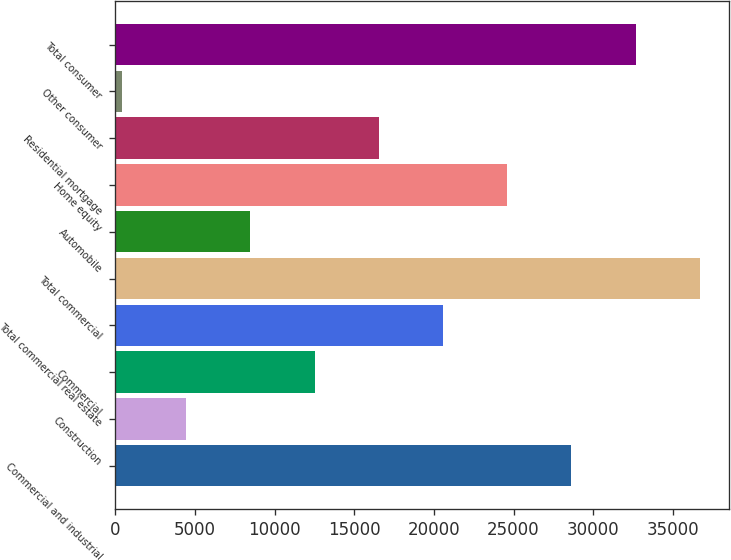Convert chart. <chart><loc_0><loc_0><loc_500><loc_500><bar_chart><fcel>Commercial and industrial<fcel>Construction<fcel>Commercial<fcel>Total commercial real estate<fcel>Total commercial<fcel>Automobile<fcel>Home equity<fcel>Residential mortgage<fcel>Other consumer<fcel>Total consumer<nl><fcel>28635.3<fcel>4449.9<fcel>12511.7<fcel>20573.5<fcel>36697.1<fcel>8480.8<fcel>24604.4<fcel>16542.6<fcel>419<fcel>32666.2<nl></chart> 